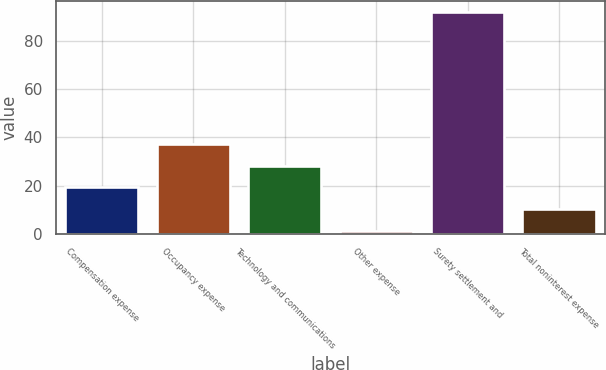Convert chart to OTSL. <chart><loc_0><loc_0><loc_500><loc_500><bar_chart><fcel>Compensation expense<fcel>Occupancy expense<fcel>Technology and communications<fcel>Other expense<fcel>Surety settlement and<fcel>Total noninterest expense<nl><fcel>19.2<fcel>37.4<fcel>28.3<fcel>1<fcel>92<fcel>10.1<nl></chart> 